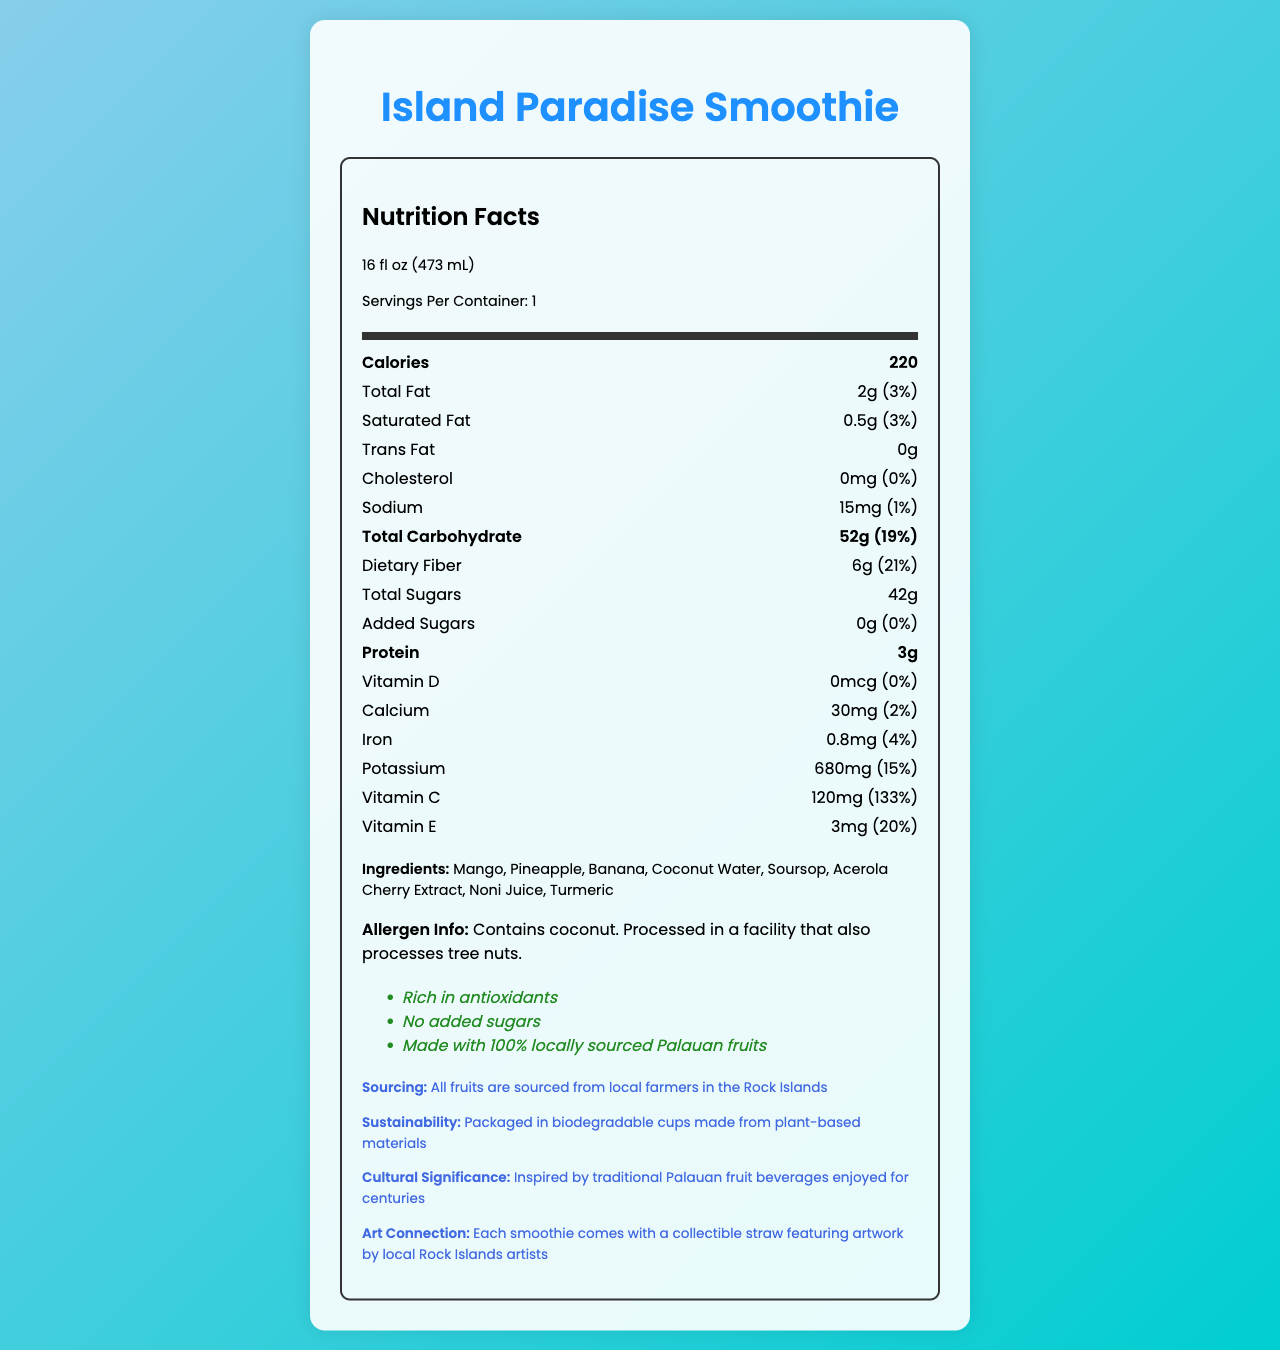what is the serving size of the Island Paradise Smoothie? The serving size information is clearly listed in the document as "16 fl oz (473 mL)".
Answer: 16 fl oz (473 mL) how many calories are there per serving? The document states that there are 220 calories per serving.
Answer: 220 what is the amount of protein in the Island Paradise Smoothie? The amount of protein is listed as 3g.
Answer: 3g what is the percentage daily value of dietary fiber in the smoothie? The percentage daily value for dietary fiber is listed as 21%.
Answer: 21% what are the main ingredients in the Island Paradise Smoothie? The document lists these ingredients in the "Ingredients" section.
Answer: Mango, Pineapple, Banana, Coconut Water, Soursop, Acerola Cherry Extract, Noni Juice, Turmeric how much Vitamin C does the smoothie provide per serving? The document states that the smoothie contains 120mg of Vitamin C per serving.
Answer: 120mg Is there any cholesterol in the Island Paradise Smoothie? The nutrition facts label states 0mg for cholesterol, which corresponds to 0% of the daily value.
Answer: No how much sugar is added to the Island Paradise Smoothie? The document specifies that there are 0g of added sugars in the smoothie.
Answer: 0g where are the fruits sourced from for the Island Paradise Smoothie? The additional information section explains that all fruits are sourced from local farmers in the Rock Islands.
Answer: Local farmers in the Rock Islands how is the packaging of the Island Paradise Smoothie environmentally friendly? A. Made from recycled plastic B. Packaged in glass bottles C. Biodegradable cups made from plant-based materials D. No packaging The document mentions that the smoothie is packaged in biodegradable cups made from plant-based materials.
Answer: C. Biodegradable cups made from plant-based materials Which of the following statements is NOT a health claim made about the Island Paradise Smoothie? A. Rich in antioxidants B. No added sugars C. Low calorie D. Made with 100% locally sourced Palauan fruits The health claims listed in the document include "Rich in antioxidants", "No added sugars", and "Made with 100% locally sourced Palauan fruits", but "Low calorie" is not mentioned.
Answer: C. Low calorie Is the Island Paradise Smoothie suitable for someone with a tree nut allergy? The allergen information states that it is processed in a facility that also processes tree nuts, therefore it may not be suitable for someone with a tree nut allergy.
Answer: No Summarize the main nutritional benefits and special features of the Island Paradise Smoothie. The document highlights both the nutritional benefits of the smoothie, such as high dietary fiber, Vitamin C, and E, and special features including locally sourced ingredients, no added sugars, environmental sustainability, and cultural significance related to local artwork.
Answer: The Island Paradise Smoothie is a 16 fl oz (473 mL) serving that provides 220 calories, 2g total fat, 6g dietary fiber, and 3g protein. It is rich in Vitamin C and E, providing 133% and 20% of daily values respectively. It is made with 100% locally sourced Palauan fruits with no added sugars, and it is rich in antioxidants. The packaging is environmentally friendly, using biodegradable cups, and celebrates local art and culture. what is the total revenue of the Island Paradise Smoothie sales last month? The document does not provide any sales or revenue information, hence the total revenue cannot be determined.
Answer: Cannot be determined 